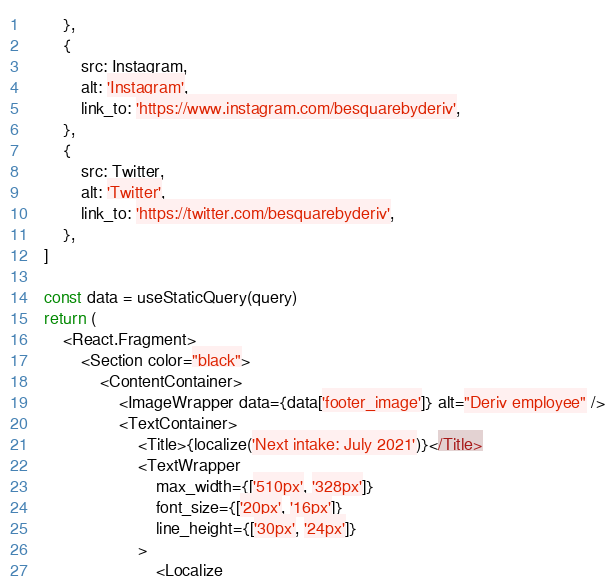<code> <loc_0><loc_0><loc_500><loc_500><_JavaScript_>        },
        {
            src: Instagram,
            alt: 'Instagram',
            link_to: 'https://www.instagram.com/besquarebyderiv',
        },
        {
            src: Twitter,
            alt: 'Twitter',
            link_to: 'https://twitter.com/besquarebyderiv',
        },
    ]

    const data = useStaticQuery(query)
    return (
        <React.Fragment>
            <Section color="black">
                <ContentContainer>
                    <ImageWrapper data={data['footer_image']} alt="Deriv employee" />
                    <TextContainer>
                        <Title>{localize('Next intake: July 2021')}</Title>
                        <TextWrapper
                            max_width={['510px', '328px']}
                            font_size={['20px', '16px']}
                            line_height={['30px', '24px']}
                        >
                            <Localize</code> 